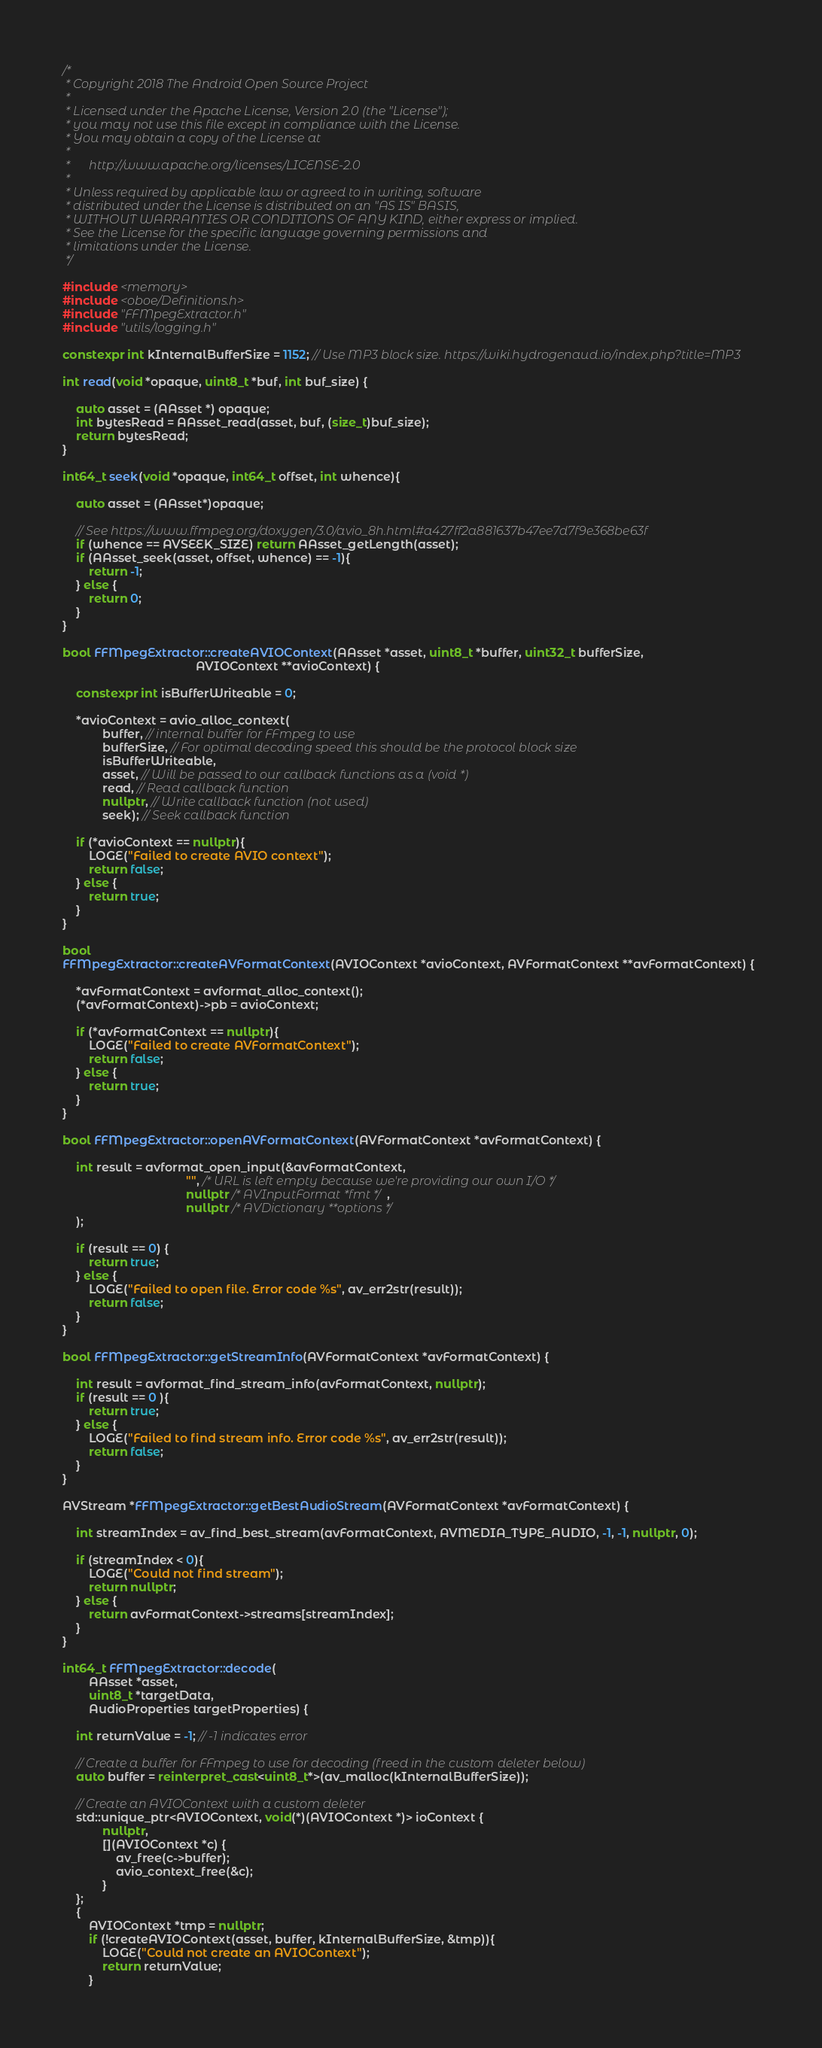<code> <loc_0><loc_0><loc_500><loc_500><_C++_>/*
 * Copyright 2018 The Android Open Source Project
 *
 * Licensed under the Apache License, Version 2.0 (the "License");
 * you may not use this file except in compliance with the License.
 * You may obtain a copy of the License at
 *
 *      http://www.apache.org/licenses/LICENSE-2.0
 *
 * Unless required by applicable law or agreed to in writing, software
 * distributed under the License is distributed on an "AS IS" BASIS,
 * WITHOUT WARRANTIES OR CONDITIONS OF ANY KIND, either express or implied.
 * See the License for the specific language governing permissions and
 * limitations under the License.
 */

#include <memory>
#include <oboe/Definitions.h>
#include "FFMpegExtractor.h"
#include "utils/logging.h"

constexpr int kInternalBufferSize = 1152; // Use MP3 block size. https://wiki.hydrogenaud.io/index.php?title=MP3

int read(void *opaque, uint8_t *buf, int buf_size) {

    auto asset = (AAsset *) opaque;
    int bytesRead = AAsset_read(asset, buf, (size_t)buf_size);
    return bytesRead;
}

int64_t seek(void *opaque, int64_t offset, int whence){

    auto asset = (AAsset*)opaque;

    // See https://www.ffmpeg.org/doxygen/3.0/avio_8h.html#a427ff2a881637b47ee7d7f9e368be63f
    if (whence == AVSEEK_SIZE) return AAsset_getLength(asset);
    if (AAsset_seek(asset, offset, whence) == -1){
        return -1;
    } else {
        return 0;
    }
}

bool FFMpegExtractor::createAVIOContext(AAsset *asset, uint8_t *buffer, uint32_t bufferSize,
                                        AVIOContext **avioContext) {

    constexpr int isBufferWriteable = 0;

    *avioContext = avio_alloc_context(
            buffer, // internal buffer for FFmpeg to use
            bufferSize, // For optimal decoding speed this should be the protocol block size
            isBufferWriteable,
            asset, // Will be passed to our callback functions as a (void *)
            read, // Read callback function
            nullptr, // Write callback function (not used)
            seek); // Seek callback function

    if (*avioContext == nullptr){
        LOGE("Failed to create AVIO context");
        return false;
    } else {
        return true;
    }
}

bool
FFMpegExtractor::createAVFormatContext(AVIOContext *avioContext, AVFormatContext **avFormatContext) {

    *avFormatContext = avformat_alloc_context();
    (*avFormatContext)->pb = avioContext;

    if (*avFormatContext == nullptr){
        LOGE("Failed to create AVFormatContext");
        return false;
    } else {
        return true;
    }
}

bool FFMpegExtractor::openAVFormatContext(AVFormatContext *avFormatContext) {

    int result = avformat_open_input(&avFormatContext,
                                     "", /* URL is left empty because we're providing our own I/O */
                                     nullptr /* AVInputFormat *fmt */,
                                     nullptr /* AVDictionary **options */
    );

    if (result == 0) {
        return true;
    } else {
        LOGE("Failed to open file. Error code %s", av_err2str(result));
        return false;
    }
}

bool FFMpegExtractor::getStreamInfo(AVFormatContext *avFormatContext) {

    int result = avformat_find_stream_info(avFormatContext, nullptr);
    if (result == 0 ){
        return true;
    } else {
        LOGE("Failed to find stream info. Error code %s", av_err2str(result));
        return false;
    }
}

AVStream *FFMpegExtractor::getBestAudioStream(AVFormatContext *avFormatContext) {
    
    int streamIndex = av_find_best_stream(avFormatContext, AVMEDIA_TYPE_AUDIO, -1, -1, nullptr, 0);

    if (streamIndex < 0){
        LOGE("Could not find stream");
        return nullptr;
    } else {
        return avFormatContext->streams[streamIndex];
    }
}

int64_t FFMpegExtractor::decode(
        AAsset *asset,
        uint8_t *targetData,
        AudioProperties targetProperties) {

    int returnValue = -1; // -1 indicates error

    // Create a buffer for FFmpeg to use for decoding (freed in the custom deleter below)
    auto buffer = reinterpret_cast<uint8_t*>(av_malloc(kInternalBufferSize));

    // Create an AVIOContext with a custom deleter
    std::unique_ptr<AVIOContext, void(*)(AVIOContext *)> ioContext {
            nullptr,
            [](AVIOContext *c) {
                av_free(c->buffer);
                avio_context_free(&c);
            }
    };
    {
        AVIOContext *tmp = nullptr;
        if (!createAVIOContext(asset, buffer, kInternalBufferSize, &tmp)){
            LOGE("Could not create an AVIOContext");
            return returnValue;
        }</code> 